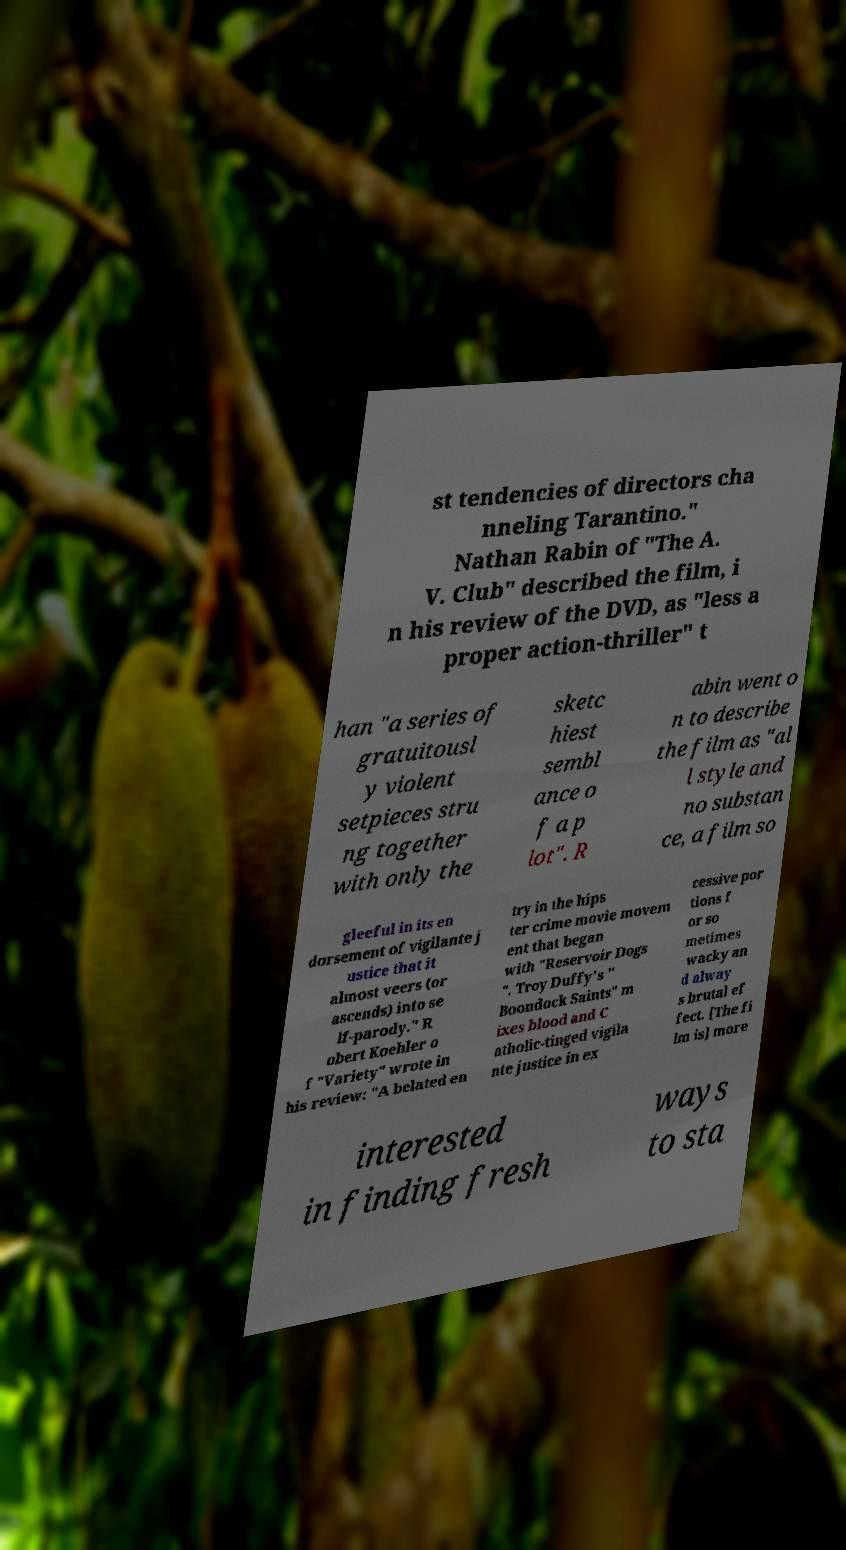Can you read and provide the text displayed in the image?This photo seems to have some interesting text. Can you extract and type it out for me? st tendencies of directors cha nneling Tarantino." Nathan Rabin of "The A. V. Club" described the film, i n his review of the DVD, as "less a proper action-thriller" t han "a series of gratuitousl y violent setpieces stru ng together with only the sketc hiest sembl ance o f a p lot". R abin went o n to describe the film as "al l style and no substan ce, a film so gleeful in its en dorsement of vigilante j ustice that it almost veers (or ascends) into se lf-parody." R obert Koehler o f "Variety" wrote in his review: "A belated en try in the hips ter crime movie movem ent that began with "Reservoir Dogs ", Troy Duffy's " Boondock Saints" m ixes blood and C atholic-tinged vigila nte justice in ex cessive por tions f or so metimes wacky an d alway s brutal ef fect. [The fi lm is] more interested in finding fresh ways to sta 